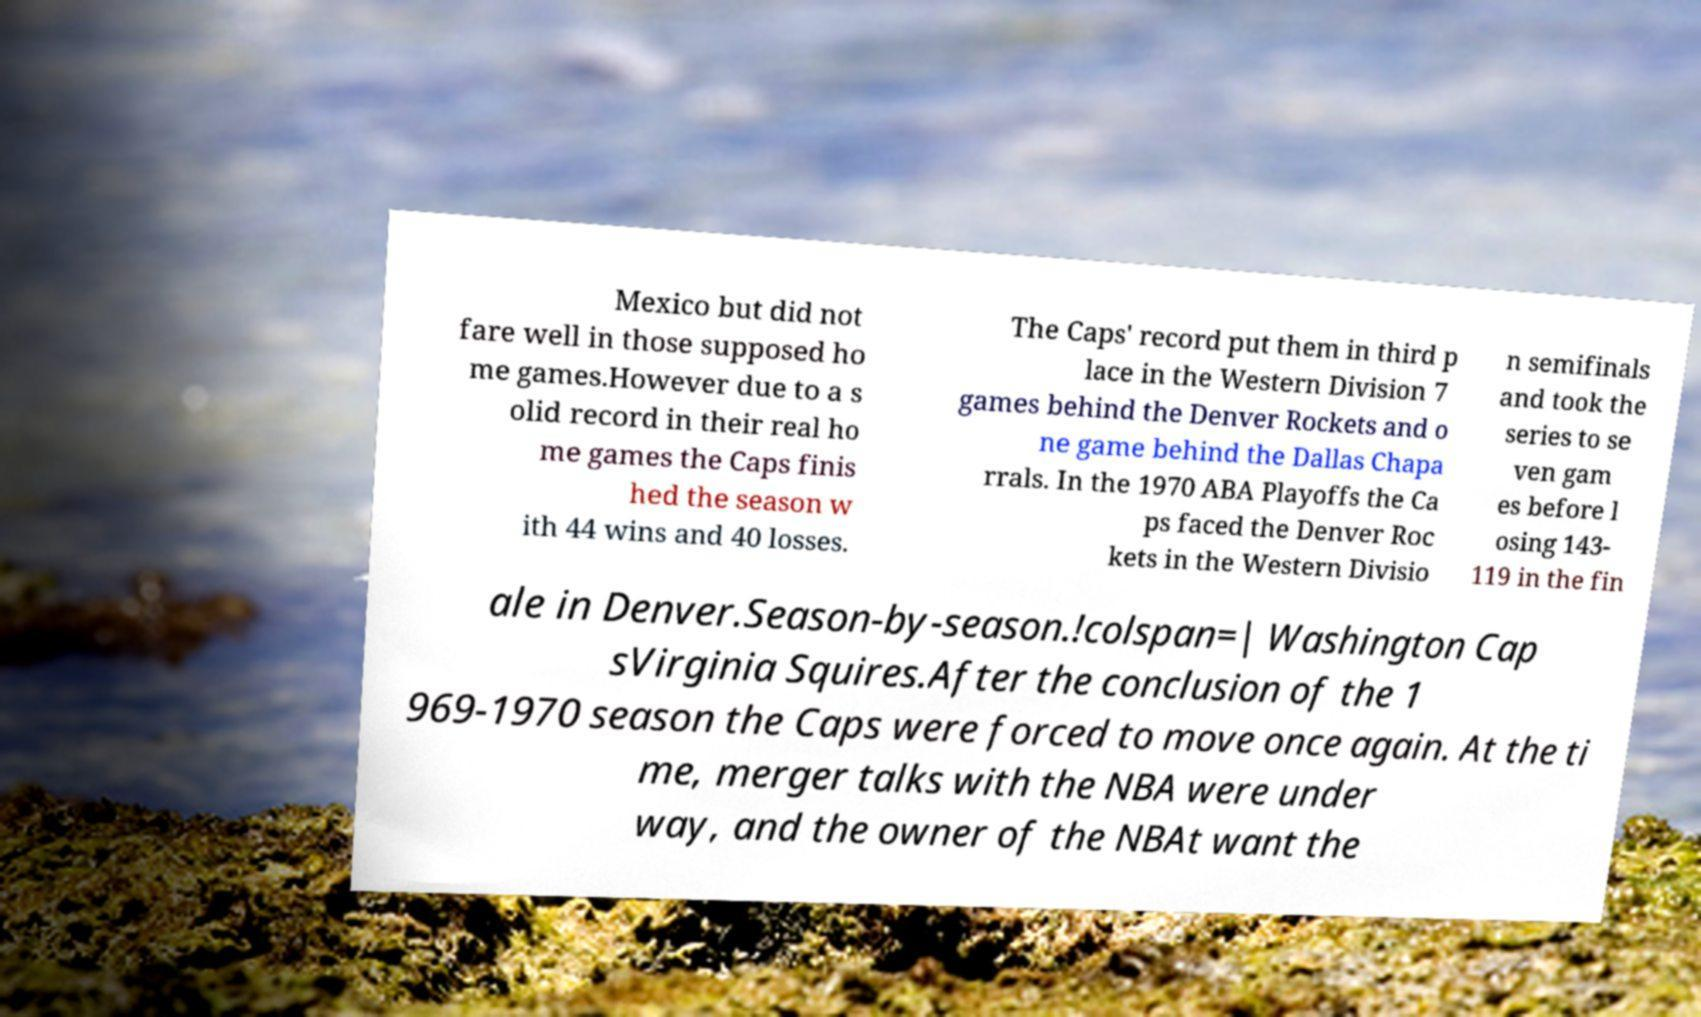Can you accurately transcribe the text from the provided image for me? Mexico but did not fare well in those supposed ho me games.However due to a s olid record in their real ho me games the Caps finis hed the season w ith 44 wins and 40 losses. The Caps' record put them in third p lace in the Western Division 7 games behind the Denver Rockets and o ne game behind the Dallas Chapa rrals. In the 1970 ABA Playoffs the Ca ps faced the Denver Roc kets in the Western Divisio n semifinals and took the series to se ven gam es before l osing 143- 119 in the fin ale in Denver.Season-by-season.!colspan=| Washington Cap sVirginia Squires.After the conclusion of the 1 969-1970 season the Caps were forced to move once again. At the ti me, merger talks with the NBA were under way, and the owner of the NBAt want the 